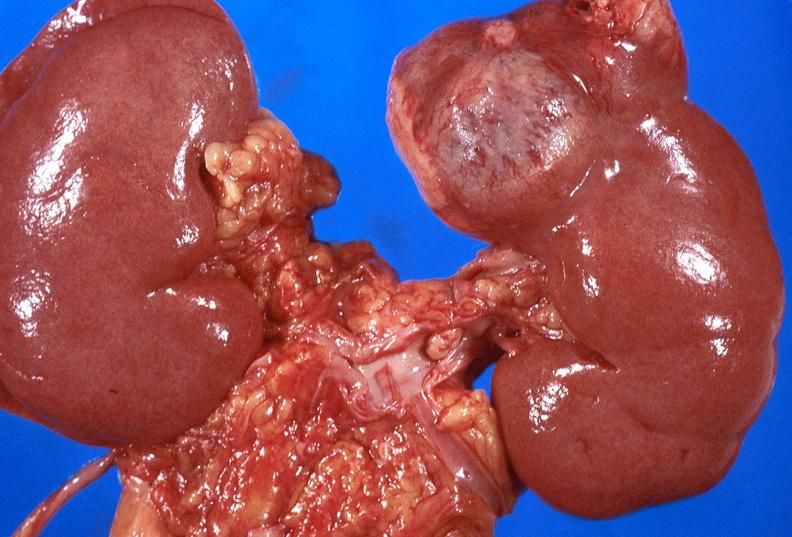does this image show renal cell carcinoma with extension into vena cava?
Answer the question using a single word or phrase. Yes 